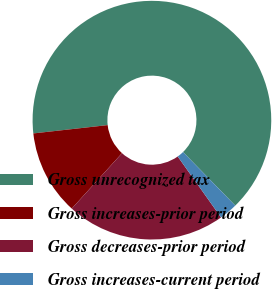<chart> <loc_0><loc_0><loc_500><loc_500><pie_chart><fcel>Gross unrecognized tax<fcel>Gross increases-prior period<fcel>Gross decreases-prior period<fcel>Gross increases-current period<nl><fcel>64.47%<fcel>11.51%<fcel>21.55%<fcel>2.47%<nl></chart> 